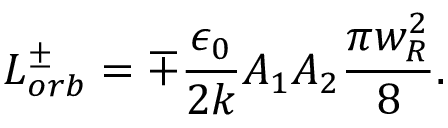Convert formula to latex. <formula><loc_0><loc_0><loc_500><loc_500>L _ { o r b } ^ { \pm } = \mp \frac { \epsilon _ { 0 } } { 2 k } A _ { 1 } A _ { 2 } \frac { \pi w _ { R } ^ { 2 } } { 8 } .</formula> 